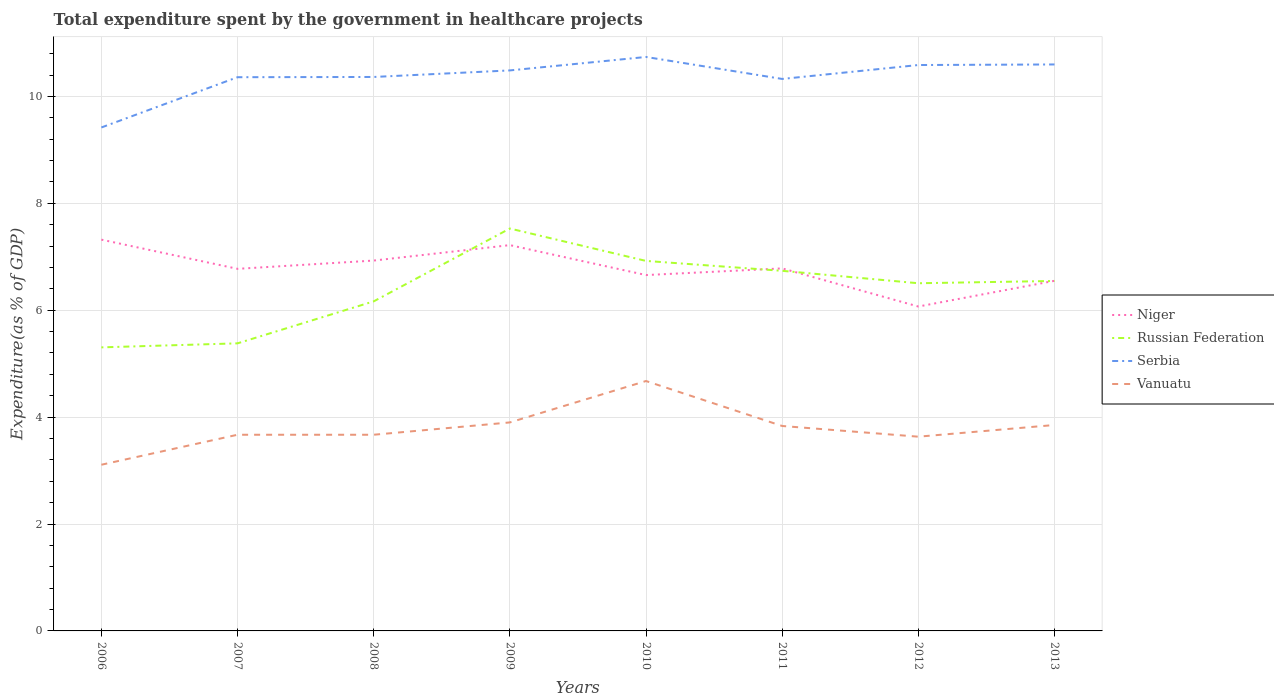How many different coloured lines are there?
Provide a short and direct response. 4. Across all years, what is the maximum total expenditure spent by the government in healthcare projects in Niger?
Provide a succinct answer. 6.07. What is the total total expenditure spent by the government in healthcare projects in Serbia in the graph?
Make the answer very short. 0.14. What is the difference between the highest and the second highest total expenditure spent by the government in healthcare projects in Niger?
Your response must be concise. 1.25. What is the difference between the highest and the lowest total expenditure spent by the government in healthcare projects in Serbia?
Provide a succinct answer. 5. How many lines are there?
Offer a very short reply. 4. How many years are there in the graph?
Make the answer very short. 8. Are the values on the major ticks of Y-axis written in scientific E-notation?
Your answer should be compact. No. Does the graph contain any zero values?
Offer a terse response. No. How are the legend labels stacked?
Make the answer very short. Vertical. What is the title of the graph?
Ensure brevity in your answer.  Total expenditure spent by the government in healthcare projects. Does "Luxembourg" appear as one of the legend labels in the graph?
Keep it short and to the point. No. What is the label or title of the Y-axis?
Offer a terse response. Expenditure(as % of GDP). What is the Expenditure(as % of GDP) of Niger in 2006?
Your response must be concise. 7.32. What is the Expenditure(as % of GDP) in Russian Federation in 2006?
Provide a short and direct response. 5.3. What is the Expenditure(as % of GDP) in Serbia in 2006?
Provide a succinct answer. 9.42. What is the Expenditure(as % of GDP) in Vanuatu in 2006?
Make the answer very short. 3.11. What is the Expenditure(as % of GDP) in Niger in 2007?
Provide a short and direct response. 6.77. What is the Expenditure(as % of GDP) of Russian Federation in 2007?
Ensure brevity in your answer.  5.38. What is the Expenditure(as % of GDP) of Serbia in 2007?
Give a very brief answer. 10.36. What is the Expenditure(as % of GDP) of Vanuatu in 2007?
Your answer should be very brief. 3.67. What is the Expenditure(as % of GDP) in Niger in 2008?
Your answer should be compact. 6.93. What is the Expenditure(as % of GDP) of Russian Federation in 2008?
Ensure brevity in your answer.  6.17. What is the Expenditure(as % of GDP) in Serbia in 2008?
Your answer should be compact. 10.36. What is the Expenditure(as % of GDP) in Vanuatu in 2008?
Offer a very short reply. 3.67. What is the Expenditure(as % of GDP) of Niger in 2009?
Offer a very short reply. 7.22. What is the Expenditure(as % of GDP) in Russian Federation in 2009?
Your answer should be very brief. 7.53. What is the Expenditure(as % of GDP) in Serbia in 2009?
Your response must be concise. 10.49. What is the Expenditure(as % of GDP) in Vanuatu in 2009?
Your answer should be compact. 3.9. What is the Expenditure(as % of GDP) of Niger in 2010?
Your response must be concise. 6.66. What is the Expenditure(as % of GDP) of Russian Federation in 2010?
Provide a succinct answer. 6.92. What is the Expenditure(as % of GDP) in Serbia in 2010?
Ensure brevity in your answer.  10.74. What is the Expenditure(as % of GDP) in Vanuatu in 2010?
Provide a short and direct response. 4.68. What is the Expenditure(as % of GDP) of Niger in 2011?
Your response must be concise. 6.78. What is the Expenditure(as % of GDP) in Russian Federation in 2011?
Give a very brief answer. 6.74. What is the Expenditure(as % of GDP) in Serbia in 2011?
Make the answer very short. 10.33. What is the Expenditure(as % of GDP) in Vanuatu in 2011?
Provide a short and direct response. 3.83. What is the Expenditure(as % of GDP) of Niger in 2012?
Ensure brevity in your answer.  6.07. What is the Expenditure(as % of GDP) in Russian Federation in 2012?
Your response must be concise. 6.5. What is the Expenditure(as % of GDP) in Serbia in 2012?
Your response must be concise. 10.59. What is the Expenditure(as % of GDP) in Vanuatu in 2012?
Keep it short and to the point. 3.63. What is the Expenditure(as % of GDP) of Niger in 2013?
Your answer should be compact. 6.55. What is the Expenditure(as % of GDP) of Russian Federation in 2013?
Offer a terse response. 6.55. What is the Expenditure(as % of GDP) in Serbia in 2013?
Your answer should be compact. 10.6. What is the Expenditure(as % of GDP) of Vanuatu in 2013?
Your answer should be very brief. 3.85. Across all years, what is the maximum Expenditure(as % of GDP) of Niger?
Keep it short and to the point. 7.32. Across all years, what is the maximum Expenditure(as % of GDP) in Russian Federation?
Offer a terse response. 7.53. Across all years, what is the maximum Expenditure(as % of GDP) in Serbia?
Ensure brevity in your answer.  10.74. Across all years, what is the maximum Expenditure(as % of GDP) of Vanuatu?
Ensure brevity in your answer.  4.68. Across all years, what is the minimum Expenditure(as % of GDP) in Niger?
Your answer should be very brief. 6.07. Across all years, what is the minimum Expenditure(as % of GDP) of Russian Federation?
Offer a very short reply. 5.3. Across all years, what is the minimum Expenditure(as % of GDP) of Serbia?
Make the answer very short. 9.42. Across all years, what is the minimum Expenditure(as % of GDP) of Vanuatu?
Provide a short and direct response. 3.11. What is the total Expenditure(as % of GDP) in Niger in the graph?
Your answer should be very brief. 54.3. What is the total Expenditure(as % of GDP) of Russian Federation in the graph?
Provide a succinct answer. 51.09. What is the total Expenditure(as % of GDP) of Serbia in the graph?
Offer a terse response. 82.87. What is the total Expenditure(as % of GDP) of Vanuatu in the graph?
Ensure brevity in your answer.  30.34. What is the difference between the Expenditure(as % of GDP) of Niger in 2006 and that in 2007?
Your response must be concise. 0.55. What is the difference between the Expenditure(as % of GDP) of Russian Federation in 2006 and that in 2007?
Give a very brief answer. -0.08. What is the difference between the Expenditure(as % of GDP) in Serbia in 2006 and that in 2007?
Your answer should be very brief. -0.94. What is the difference between the Expenditure(as % of GDP) in Vanuatu in 2006 and that in 2007?
Your response must be concise. -0.56. What is the difference between the Expenditure(as % of GDP) in Niger in 2006 and that in 2008?
Keep it short and to the point. 0.39. What is the difference between the Expenditure(as % of GDP) of Russian Federation in 2006 and that in 2008?
Offer a terse response. -0.86. What is the difference between the Expenditure(as % of GDP) in Serbia in 2006 and that in 2008?
Provide a short and direct response. -0.94. What is the difference between the Expenditure(as % of GDP) in Vanuatu in 2006 and that in 2008?
Ensure brevity in your answer.  -0.56. What is the difference between the Expenditure(as % of GDP) in Niger in 2006 and that in 2009?
Provide a short and direct response. 0.1. What is the difference between the Expenditure(as % of GDP) in Russian Federation in 2006 and that in 2009?
Your answer should be compact. -2.22. What is the difference between the Expenditure(as % of GDP) of Serbia in 2006 and that in 2009?
Provide a short and direct response. -1.07. What is the difference between the Expenditure(as % of GDP) of Vanuatu in 2006 and that in 2009?
Give a very brief answer. -0.79. What is the difference between the Expenditure(as % of GDP) of Niger in 2006 and that in 2010?
Provide a succinct answer. 0.66. What is the difference between the Expenditure(as % of GDP) in Russian Federation in 2006 and that in 2010?
Give a very brief answer. -1.62. What is the difference between the Expenditure(as % of GDP) in Serbia in 2006 and that in 2010?
Give a very brief answer. -1.32. What is the difference between the Expenditure(as % of GDP) in Vanuatu in 2006 and that in 2010?
Give a very brief answer. -1.57. What is the difference between the Expenditure(as % of GDP) in Niger in 2006 and that in 2011?
Make the answer very short. 0.54. What is the difference between the Expenditure(as % of GDP) in Russian Federation in 2006 and that in 2011?
Your answer should be very brief. -1.43. What is the difference between the Expenditure(as % of GDP) in Serbia in 2006 and that in 2011?
Your response must be concise. -0.91. What is the difference between the Expenditure(as % of GDP) of Vanuatu in 2006 and that in 2011?
Provide a succinct answer. -0.73. What is the difference between the Expenditure(as % of GDP) in Niger in 2006 and that in 2012?
Make the answer very short. 1.25. What is the difference between the Expenditure(as % of GDP) of Russian Federation in 2006 and that in 2012?
Your answer should be very brief. -1.2. What is the difference between the Expenditure(as % of GDP) of Serbia in 2006 and that in 2012?
Your response must be concise. -1.17. What is the difference between the Expenditure(as % of GDP) in Vanuatu in 2006 and that in 2012?
Give a very brief answer. -0.52. What is the difference between the Expenditure(as % of GDP) in Niger in 2006 and that in 2013?
Your answer should be very brief. 0.77. What is the difference between the Expenditure(as % of GDP) in Russian Federation in 2006 and that in 2013?
Provide a succinct answer. -1.24. What is the difference between the Expenditure(as % of GDP) of Serbia in 2006 and that in 2013?
Make the answer very short. -1.18. What is the difference between the Expenditure(as % of GDP) of Vanuatu in 2006 and that in 2013?
Your answer should be compact. -0.74. What is the difference between the Expenditure(as % of GDP) of Niger in 2007 and that in 2008?
Offer a terse response. -0.15. What is the difference between the Expenditure(as % of GDP) of Russian Federation in 2007 and that in 2008?
Offer a terse response. -0.79. What is the difference between the Expenditure(as % of GDP) of Serbia in 2007 and that in 2008?
Provide a short and direct response. -0. What is the difference between the Expenditure(as % of GDP) in Niger in 2007 and that in 2009?
Offer a very short reply. -0.44. What is the difference between the Expenditure(as % of GDP) of Russian Federation in 2007 and that in 2009?
Provide a succinct answer. -2.15. What is the difference between the Expenditure(as % of GDP) of Serbia in 2007 and that in 2009?
Offer a terse response. -0.13. What is the difference between the Expenditure(as % of GDP) of Vanuatu in 2007 and that in 2009?
Offer a very short reply. -0.23. What is the difference between the Expenditure(as % of GDP) of Niger in 2007 and that in 2010?
Keep it short and to the point. 0.12. What is the difference between the Expenditure(as % of GDP) of Russian Federation in 2007 and that in 2010?
Provide a succinct answer. -1.54. What is the difference between the Expenditure(as % of GDP) in Serbia in 2007 and that in 2010?
Your response must be concise. -0.38. What is the difference between the Expenditure(as % of GDP) of Vanuatu in 2007 and that in 2010?
Provide a succinct answer. -1.01. What is the difference between the Expenditure(as % of GDP) in Niger in 2007 and that in 2011?
Ensure brevity in your answer.  -0.01. What is the difference between the Expenditure(as % of GDP) of Russian Federation in 2007 and that in 2011?
Ensure brevity in your answer.  -1.36. What is the difference between the Expenditure(as % of GDP) of Serbia in 2007 and that in 2011?
Provide a succinct answer. 0.03. What is the difference between the Expenditure(as % of GDP) of Vanuatu in 2007 and that in 2011?
Make the answer very short. -0.16. What is the difference between the Expenditure(as % of GDP) of Niger in 2007 and that in 2012?
Offer a terse response. 0.71. What is the difference between the Expenditure(as % of GDP) of Russian Federation in 2007 and that in 2012?
Give a very brief answer. -1.12. What is the difference between the Expenditure(as % of GDP) of Serbia in 2007 and that in 2012?
Provide a succinct answer. -0.23. What is the difference between the Expenditure(as % of GDP) of Vanuatu in 2007 and that in 2012?
Your response must be concise. 0.04. What is the difference between the Expenditure(as % of GDP) in Niger in 2007 and that in 2013?
Ensure brevity in your answer.  0.22. What is the difference between the Expenditure(as % of GDP) of Russian Federation in 2007 and that in 2013?
Give a very brief answer. -1.17. What is the difference between the Expenditure(as % of GDP) of Serbia in 2007 and that in 2013?
Make the answer very short. -0.24. What is the difference between the Expenditure(as % of GDP) in Vanuatu in 2007 and that in 2013?
Give a very brief answer. -0.18. What is the difference between the Expenditure(as % of GDP) of Niger in 2008 and that in 2009?
Provide a short and direct response. -0.29. What is the difference between the Expenditure(as % of GDP) in Russian Federation in 2008 and that in 2009?
Ensure brevity in your answer.  -1.36. What is the difference between the Expenditure(as % of GDP) in Serbia in 2008 and that in 2009?
Give a very brief answer. -0.12. What is the difference between the Expenditure(as % of GDP) of Vanuatu in 2008 and that in 2009?
Give a very brief answer. -0.23. What is the difference between the Expenditure(as % of GDP) of Niger in 2008 and that in 2010?
Provide a succinct answer. 0.27. What is the difference between the Expenditure(as % of GDP) of Russian Federation in 2008 and that in 2010?
Ensure brevity in your answer.  -0.76. What is the difference between the Expenditure(as % of GDP) in Serbia in 2008 and that in 2010?
Offer a very short reply. -0.37. What is the difference between the Expenditure(as % of GDP) in Vanuatu in 2008 and that in 2010?
Ensure brevity in your answer.  -1.01. What is the difference between the Expenditure(as % of GDP) of Niger in 2008 and that in 2011?
Your answer should be very brief. 0.15. What is the difference between the Expenditure(as % of GDP) in Russian Federation in 2008 and that in 2011?
Make the answer very short. -0.57. What is the difference between the Expenditure(as % of GDP) in Serbia in 2008 and that in 2011?
Offer a terse response. 0.04. What is the difference between the Expenditure(as % of GDP) of Vanuatu in 2008 and that in 2011?
Make the answer very short. -0.16. What is the difference between the Expenditure(as % of GDP) in Niger in 2008 and that in 2012?
Ensure brevity in your answer.  0.86. What is the difference between the Expenditure(as % of GDP) of Russian Federation in 2008 and that in 2012?
Ensure brevity in your answer.  -0.34. What is the difference between the Expenditure(as % of GDP) in Serbia in 2008 and that in 2012?
Your answer should be compact. -0.22. What is the difference between the Expenditure(as % of GDP) of Vanuatu in 2008 and that in 2012?
Provide a short and direct response. 0.04. What is the difference between the Expenditure(as % of GDP) in Niger in 2008 and that in 2013?
Your response must be concise. 0.38. What is the difference between the Expenditure(as % of GDP) of Russian Federation in 2008 and that in 2013?
Offer a very short reply. -0.38. What is the difference between the Expenditure(as % of GDP) in Serbia in 2008 and that in 2013?
Your answer should be compact. -0.23. What is the difference between the Expenditure(as % of GDP) in Vanuatu in 2008 and that in 2013?
Keep it short and to the point. -0.18. What is the difference between the Expenditure(as % of GDP) in Niger in 2009 and that in 2010?
Provide a short and direct response. 0.56. What is the difference between the Expenditure(as % of GDP) in Russian Federation in 2009 and that in 2010?
Provide a succinct answer. 0.61. What is the difference between the Expenditure(as % of GDP) in Serbia in 2009 and that in 2010?
Your answer should be compact. -0.25. What is the difference between the Expenditure(as % of GDP) of Vanuatu in 2009 and that in 2010?
Provide a short and direct response. -0.77. What is the difference between the Expenditure(as % of GDP) in Niger in 2009 and that in 2011?
Make the answer very short. 0.44. What is the difference between the Expenditure(as % of GDP) of Russian Federation in 2009 and that in 2011?
Your response must be concise. 0.79. What is the difference between the Expenditure(as % of GDP) in Serbia in 2009 and that in 2011?
Provide a succinct answer. 0.16. What is the difference between the Expenditure(as % of GDP) in Vanuatu in 2009 and that in 2011?
Ensure brevity in your answer.  0.07. What is the difference between the Expenditure(as % of GDP) in Niger in 2009 and that in 2012?
Your response must be concise. 1.15. What is the difference between the Expenditure(as % of GDP) in Russian Federation in 2009 and that in 2012?
Offer a terse response. 1.02. What is the difference between the Expenditure(as % of GDP) in Serbia in 2009 and that in 2012?
Provide a succinct answer. -0.1. What is the difference between the Expenditure(as % of GDP) in Vanuatu in 2009 and that in 2012?
Your answer should be compact. 0.27. What is the difference between the Expenditure(as % of GDP) of Niger in 2009 and that in 2013?
Make the answer very short. 0.67. What is the difference between the Expenditure(as % of GDP) in Russian Federation in 2009 and that in 2013?
Give a very brief answer. 0.98. What is the difference between the Expenditure(as % of GDP) of Serbia in 2009 and that in 2013?
Offer a very short reply. -0.11. What is the difference between the Expenditure(as % of GDP) in Vanuatu in 2009 and that in 2013?
Make the answer very short. 0.05. What is the difference between the Expenditure(as % of GDP) of Niger in 2010 and that in 2011?
Offer a very short reply. -0.12. What is the difference between the Expenditure(as % of GDP) in Russian Federation in 2010 and that in 2011?
Offer a very short reply. 0.19. What is the difference between the Expenditure(as % of GDP) in Serbia in 2010 and that in 2011?
Make the answer very short. 0.41. What is the difference between the Expenditure(as % of GDP) in Vanuatu in 2010 and that in 2011?
Offer a very short reply. 0.84. What is the difference between the Expenditure(as % of GDP) in Niger in 2010 and that in 2012?
Your answer should be compact. 0.59. What is the difference between the Expenditure(as % of GDP) in Russian Federation in 2010 and that in 2012?
Your answer should be compact. 0.42. What is the difference between the Expenditure(as % of GDP) in Serbia in 2010 and that in 2012?
Give a very brief answer. 0.15. What is the difference between the Expenditure(as % of GDP) in Vanuatu in 2010 and that in 2012?
Offer a very short reply. 1.04. What is the difference between the Expenditure(as % of GDP) in Niger in 2010 and that in 2013?
Provide a short and direct response. 0.11. What is the difference between the Expenditure(as % of GDP) in Russian Federation in 2010 and that in 2013?
Your answer should be very brief. 0.37. What is the difference between the Expenditure(as % of GDP) in Serbia in 2010 and that in 2013?
Provide a succinct answer. 0.14. What is the difference between the Expenditure(as % of GDP) of Vanuatu in 2010 and that in 2013?
Your response must be concise. 0.82. What is the difference between the Expenditure(as % of GDP) of Niger in 2011 and that in 2012?
Provide a succinct answer. 0.71. What is the difference between the Expenditure(as % of GDP) of Russian Federation in 2011 and that in 2012?
Your answer should be compact. 0.23. What is the difference between the Expenditure(as % of GDP) in Serbia in 2011 and that in 2012?
Your response must be concise. -0.26. What is the difference between the Expenditure(as % of GDP) of Vanuatu in 2011 and that in 2012?
Your answer should be very brief. 0.2. What is the difference between the Expenditure(as % of GDP) of Niger in 2011 and that in 2013?
Keep it short and to the point. 0.23. What is the difference between the Expenditure(as % of GDP) in Russian Federation in 2011 and that in 2013?
Provide a succinct answer. 0.19. What is the difference between the Expenditure(as % of GDP) of Serbia in 2011 and that in 2013?
Provide a short and direct response. -0.27. What is the difference between the Expenditure(as % of GDP) in Vanuatu in 2011 and that in 2013?
Give a very brief answer. -0.02. What is the difference between the Expenditure(as % of GDP) of Niger in 2012 and that in 2013?
Your answer should be very brief. -0.48. What is the difference between the Expenditure(as % of GDP) of Russian Federation in 2012 and that in 2013?
Offer a terse response. -0.04. What is the difference between the Expenditure(as % of GDP) in Serbia in 2012 and that in 2013?
Give a very brief answer. -0.01. What is the difference between the Expenditure(as % of GDP) of Vanuatu in 2012 and that in 2013?
Provide a succinct answer. -0.22. What is the difference between the Expenditure(as % of GDP) in Niger in 2006 and the Expenditure(as % of GDP) in Russian Federation in 2007?
Your answer should be compact. 1.94. What is the difference between the Expenditure(as % of GDP) in Niger in 2006 and the Expenditure(as % of GDP) in Serbia in 2007?
Make the answer very short. -3.04. What is the difference between the Expenditure(as % of GDP) in Niger in 2006 and the Expenditure(as % of GDP) in Vanuatu in 2007?
Your answer should be very brief. 3.65. What is the difference between the Expenditure(as % of GDP) in Russian Federation in 2006 and the Expenditure(as % of GDP) in Serbia in 2007?
Your answer should be very brief. -5.05. What is the difference between the Expenditure(as % of GDP) of Russian Federation in 2006 and the Expenditure(as % of GDP) of Vanuatu in 2007?
Offer a terse response. 1.63. What is the difference between the Expenditure(as % of GDP) of Serbia in 2006 and the Expenditure(as % of GDP) of Vanuatu in 2007?
Your answer should be compact. 5.75. What is the difference between the Expenditure(as % of GDP) of Niger in 2006 and the Expenditure(as % of GDP) of Russian Federation in 2008?
Your answer should be very brief. 1.15. What is the difference between the Expenditure(as % of GDP) of Niger in 2006 and the Expenditure(as % of GDP) of Serbia in 2008?
Your answer should be compact. -3.04. What is the difference between the Expenditure(as % of GDP) of Niger in 2006 and the Expenditure(as % of GDP) of Vanuatu in 2008?
Keep it short and to the point. 3.65. What is the difference between the Expenditure(as % of GDP) in Russian Federation in 2006 and the Expenditure(as % of GDP) in Serbia in 2008?
Offer a very short reply. -5.06. What is the difference between the Expenditure(as % of GDP) of Russian Federation in 2006 and the Expenditure(as % of GDP) of Vanuatu in 2008?
Offer a very short reply. 1.63. What is the difference between the Expenditure(as % of GDP) in Serbia in 2006 and the Expenditure(as % of GDP) in Vanuatu in 2008?
Your response must be concise. 5.75. What is the difference between the Expenditure(as % of GDP) in Niger in 2006 and the Expenditure(as % of GDP) in Russian Federation in 2009?
Give a very brief answer. -0.21. What is the difference between the Expenditure(as % of GDP) in Niger in 2006 and the Expenditure(as % of GDP) in Serbia in 2009?
Make the answer very short. -3.17. What is the difference between the Expenditure(as % of GDP) of Niger in 2006 and the Expenditure(as % of GDP) of Vanuatu in 2009?
Keep it short and to the point. 3.42. What is the difference between the Expenditure(as % of GDP) in Russian Federation in 2006 and the Expenditure(as % of GDP) in Serbia in 2009?
Your answer should be compact. -5.18. What is the difference between the Expenditure(as % of GDP) in Russian Federation in 2006 and the Expenditure(as % of GDP) in Vanuatu in 2009?
Your answer should be very brief. 1.4. What is the difference between the Expenditure(as % of GDP) in Serbia in 2006 and the Expenditure(as % of GDP) in Vanuatu in 2009?
Offer a very short reply. 5.52. What is the difference between the Expenditure(as % of GDP) in Niger in 2006 and the Expenditure(as % of GDP) in Russian Federation in 2010?
Your answer should be compact. 0.4. What is the difference between the Expenditure(as % of GDP) of Niger in 2006 and the Expenditure(as % of GDP) of Serbia in 2010?
Offer a terse response. -3.42. What is the difference between the Expenditure(as % of GDP) of Niger in 2006 and the Expenditure(as % of GDP) of Vanuatu in 2010?
Your response must be concise. 2.64. What is the difference between the Expenditure(as % of GDP) of Russian Federation in 2006 and the Expenditure(as % of GDP) of Serbia in 2010?
Your answer should be very brief. -5.43. What is the difference between the Expenditure(as % of GDP) in Russian Federation in 2006 and the Expenditure(as % of GDP) in Vanuatu in 2010?
Your answer should be compact. 0.63. What is the difference between the Expenditure(as % of GDP) in Serbia in 2006 and the Expenditure(as % of GDP) in Vanuatu in 2010?
Offer a terse response. 4.74. What is the difference between the Expenditure(as % of GDP) of Niger in 2006 and the Expenditure(as % of GDP) of Russian Federation in 2011?
Give a very brief answer. 0.58. What is the difference between the Expenditure(as % of GDP) in Niger in 2006 and the Expenditure(as % of GDP) in Serbia in 2011?
Offer a terse response. -3.01. What is the difference between the Expenditure(as % of GDP) of Niger in 2006 and the Expenditure(as % of GDP) of Vanuatu in 2011?
Provide a succinct answer. 3.49. What is the difference between the Expenditure(as % of GDP) in Russian Federation in 2006 and the Expenditure(as % of GDP) in Serbia in 2011?
Provide a short and direct response. -5.02. What is the difference between the Expenditure(as % of GDP) in Russian Federation in 2006 and the Expenditure(as % of GDP) in Vanuatu in 2011?
Ensure brevity in your answer.  1.47. What is the difference between the Expenditure(as % of GDP) in Serbia in 2006 and the Expenditure(as % of GDP) in Vanuatu in 2011?
Your answer should be very brief. 5.58. What is the difference between the Expenditure(as % of GDP) of Niger in 2006 and the Expenditure(as % of GDP) of Russian Federation in 2012?
Give a very brief answer. 0.82. What is the difference between the Expenditure(as % of GDP) of Niger in 2006 and the Expenditure(as % of GDP) of Serbia in 2012?
Your answer should be very brief. -3.27. What is the difference between the Expenditure(as % of GDP) in Niger in 2006 and the Expenditure(as % of GDP) in Vanuatu in 2012?
Keep it short and to the point. 3.69. What is the difference between the Expenditure(as % of GDP) of Russian Federation in 2006 and the Expenditure(as % of GDP) of Serbia in 2012?
Provide a succinct answer. -5.28. What is the difference between the Expenditure(as % of GDP) of Russian Federation in 2006 and the Expenditure(as % of GDP) of Vanuatu in 2012?
Provide a short and direct response. 1.67. What is the difference between the Expenditure(as % of GDP) of Serbia in 2006 and the Expenditure(as % of GDP) of Vanuatu in 2012?
Your answer should be very brief. 5.78. What is the difference between the Expenditure(as % of GDP) of Niger in 2006 and the Expenditure(as % of GDP) of Russian Federation in 2013?
Your answer should be compact. 0.77. What is the difference between the Expenditure(as % of GDP) of Niger in 2006 and the Expenditure(as % of GDP) of Serbia in 2013?
Your answer should be compact. -3.28. What is the difference between the Expenditure(as % of GDP) in Niger in 2006 and the Expenditure(as % of GDP) in Vanuatu in 2013?
Offer a very short reply. 3.47. What is the difference between the Expenditure(as % of GDP) in Russian Federation in 2006 and the Expenditure(as % of GDP) in Serbia in 2013?
Give a very brief answer. -5.29. What is the difference between the Expenditure(as % of GDP) of Russian Federation in 2006 and the Expenditure(as % of GDP) of Vanuatu in 2013?
Give a very brief answer. 1.45. What is the difference between the Expenditure(as % of GDP) of Serbia in 2006 and the Expenditure(as % of GDP) of Vanuatu in 2013?
Your response must be concise. 5.57. What is the difference between the Expenditure(as % of GDP) in Niger in 2007 and the Expenditure(as % of GDP) in Russian Federation in 2008?
Keep it short and to the point. 0.61. What is the difference between the Expenditure(as % of GDP) in Niger in 2007 and the Expenditure(as % of GDP) in Serbia in 2008?
Keep it short and to the point. -3.59. What is the difference between the Expenditure(as % of GDP) of Niger in 2007 and the Expenditure(as % of GDP) of Vanuatu in 2008?
Your answer should be very brief. 3.1. What is the difference between the Expenditure(as % of GDP) of Russian Federation in 2007 and the Expenditure(as % of GDP) of Serbia in 2008?
Your answer should be compact. -4.98. What is the difference between the Expenditure(as % of GDP) of Russian Federation in 2007 and the Expenditure(as % of GDP) of Vanuatu in 2008?
Keep it short and to the point. 1.71. What is the difference between the Expenditure(as % of GDP) in Serbia in 2007 and the Expenditure(as % of GDP) in Vanuatu in 2008?
Your response must be concise. 6.69. What is the difference between the Expenditure(as % of GDP) in Niger in 2007 and the Expenditure(as % of GDP) in Russian Federation in 2009?
Offer a terse response. -0.75. What is the difference between the Expenditure(as % of GDP) in Niger in 2007 and the Expenditure(as % of GDP) in Serbia in 2009?
Ensure brevity in your answer.  -3.71. What is the difference between the Expenditure(as % of GDP) in Niger in 2007 and the Expenditure(as % of GDP) in Vanuatu in 2009?
Ensure brevity in your answer.  2.87. What is the difference between the Expenditure(as % of GDP) of Russian Federation in 2007 and the Expenditure(as % of GDP) of Serbia in 2009?
Ensure brevity in your answer.  -5.11. What is the difference between the Expenditure(as % of GDP) of Russian Federation in 2007 and the Expenditure(as % of GDP) of Vanuatu in 2009?
Ensure brevity in your answer.  1.48. What is the difference between the Expenditure(as % of GDP) in Serbia in 2007 and the Expenditure(as % of GDP) in Vanuatu in 2009?
Make the answer very short. 6.46. What is the difference between the Expenditure(as % of GDP) in Niger in 2007 and the Expenditure(as % of GDP) in Russian Federation in 2010?
Offer a very short reply. -0.15. What is the difference between the Expenditure(as % of GDP) of Niger in 2007 and the Expenditure(as % of GDP) of Serbia in 2010?
Make the answer very short. -3.96. What is the difference between the Expenditure(as % of GDP) in Niger in 2007 and the Expenditure(as % of GDP) in Vanuatu in 2010?
Your answer should be compact. 2.1. What is the difference between the Expenditure(as % of GDP) of Russian Federation in 2007 and the Expenditure(as % of GDP) of Serbia in 2010?
Provide a short and direct response. -5.36. What is the difference between the Expenditure(as % of GDP) of Russian Federation in 2007 and the Expenditure(as % of GDP) of Vanuatu in 2010?
Provide a short and direct response. 0.7. What is the difference between the Expenditure(as % of GDP) of Serbia in 2007 and the Expenditure(as % of GDP) of Vanuatu in 2010?
Provide a succinct answer. 5.68. What is the difference between the Expenditure(as % of GDP) in Niger in 2007 and the Expenditure(as % of GDP) in Russian Federation in 2011?
Provide a short and direct response. 0.04. What is the difference between the Expenditure(as % of GDP) in Niger in 2007 and the Expenditure(as % of GDP) in Serbia in 2011?
Your answer should be very brief. -3.55. What is the difference between the Expenditure(as % of GDP) in Niger in 2007 and the Expenditure(as % of GDP) in Vanuatu in 2011?
Ensure brevity in your answer.  2.94. What is the difference between the Expenditure(as % of GDP) of Russian Federation in 2007 and the Expenditure(as % of GDP) of Serbia in 2011?
Give a very brief answer. -4.95. What is the difference between the Expenditure(as % of GDP) of Russian Federation in 2007 and the Expenditure(as % of GDP) of Vanuatu in 2011?
Make the answer very short. 1.55. What is the difference between the Expenditure(as % of GDP) of Serbia in 2007 and the Expenditure(as % of GDP) of Vanuatu in 2011?
Make the answer very short. 6.52. What is the difference between the Expenditure(as % of GDP) of Niger in 2007 and the Expenditure(as % of GDP) of Russian Federation in 2012?
Your answer should be very brief. 0.27. What is the difference between the Expenditure(as % of GDP) of Niger in 2007 and the Expenditure(as % of GDP) of Serbia in 2012?
Keep it short and to the point. -3.81. What is the difference between the Expenditure(as % of GDP) of Niger in 2007 and the Expenditure(as % of GDP) of Vanuatu in 2012?
Offer a terse response. 3.14. What is the difference between the Expenditure(as % of GDP) of Russian Federation in 2007 and the Expenditure(as % of GDP) of Serbia in 2012?
Offer a terse response. -5.21. What is the difference between the Expenditure(as % of GDP) in Russian Federation in 2007 and the Expenditure(as % of GDP) in Vanuatu in 2012?
Your answer should be compact. 1.75. What is the difference between the Expenditure(as % of GDP) in Serbia in 2007 and the Expenditure(as % of GDP) in Vanuatu in 2012?
Provide a succinct answer. 6.73. What is the difference between the Expenditure(as % of GDP) in Niger in 2007 and the Expenditure(as % of GDP) in Russian Federation in 2013?
Your response must be concise. 0.23. What is the difference between the Expenditure(as % of GDP) of Niger in 2007 and the Expenditure(as % of GDP) of Serbia in 2013?
Give a very brief answer. -3.82. What is the difference between the Expenditure(as % of GDP) in Niger in 2007 and the Expenditure(as % of GDP) in Vanuatu in 2013?
Your answer should be very brief. 2.92. What is the difference between the Expenditure(as % of GDP) of Russian Federation in 2007 and the Expenditure(as % of GDP) of Serbia in 2013?
Your answer should be compact. -5.22. What is the difference between the Expenditure(as % of GDP) in Russian Federation in 2007 and the Expenditure(as % of GDP) in Vanuatu in 2013?
Make the answer very short. 1.53. What is the difference between the Expenditure(as % of GDP) in Serbia in 2007 and the Expenditure(as % of GDP) in Vanuatu in 2013?
Your response must be concise. 6.51. What is the difference between the Expenditure(as % of GDP) in Niger in 2008 and the Expenditure(as % of GDP) in Russian Federation in 2009?
Your answer should be compact. -0.6. What is the difference between the Expenditure(as % of GDP) of Niger in 2008 and the Expenditure(as % of GDP) of Serbia in 2009?
Ensure brevity in your answer.  -3.56. What is the difference between the Expenditure(as % of GDP) of Niger in 2008 and the Expenditure(as % of GDP) of Vanuatu in 2009?
Your response must be concise. 3.03. What is the difference between the Expenditure(as % of GDP) of Russian Federation in 2008 and the Expenditure(as % of GDP) of Serbia in 2009?
Provide a short and direct response. -4.32. What is the difference between the Expenditure(as % of GDP) of Russian Federation in 2008 and the Expenditure(as % of GDP) of Vanuatu in 2009?
Make the answer very short. 2.26. What is the difference between the Expenditure(as % of GDP) of Serbia in 2008 and the Expenditure(as % of GDP) of Vanuatu in 2009?
Give a very brief answer. 6.46. What is the difference between the Expenditure(as % of GDP) in Niger in 2008 and the Expenditure(as % of GDP) in Russian Federation in 2010?
Make the answer very short. 0.01. What is the difference between the Expenditure(as % of GDP) in Niger in 2008 and the Expenditure(as % of GDP) in Serbia in 2010?
Give a very brief answer. -3.81. What is the difference between the Expenditure(as % of GDP) in Niger in 2008 and the Expenditure(as % of GDP) in Vanuatu in 2010?
Offer a very short reply. 2.25. What is the difference between the Expenditure(as % of GDP) of Russian Federation in 2008 and the Expenditure(as % of GDP) of Serbia in 2010?
Your answer should be very brief. -4.57. What is the difference between the Expenditure(as % of GDP) in Russian Federation in 2008 and the Expenditure(as % of GDP) in Vanuatu in 2010?
Give a very brief answer. 1.49. What is the difference between the Expenditure(as % of GDP) of Serbia in 2008 and the Expenditure(as % of GDP) of Vanuatu in 2010?
Provide a short and direct response. 5.69. What is the difference between the Expenditure(as % of GDP) in Niger in 2008 and the Expenditure(as % of GDP) in Russian Federation in 2011?
Your answer should be very brief. 0.19. What is the difference between the Expenditure(as % of GDP) in Niger in 2008 and the Expenditure(as % of GDP) in Serbia in 2011?
Make the answer very short. -3.4. What is the difference between the Expenditure(as % of GDP) in Niger in 2008 and the Expenditure(as % of GDP) in Vanuatu in 2011?
Keep it short and to the point. 3.09. What is the difference between the Expenditure(as % of GDP) of Russian Federation in 2008 and the Expenditure(as % of GDP) of Serbia in 2011?
Your response must be concise. -4.16. What is the difference between the Expenditure(as % of GDP) in Russian Federation in 2008 and the Expenditure(as % of GDP) in Vanuatu in 2011?
Make the answer very short. 2.33. What is the difference between the Expenditure(as % of GDP) in Serbia in 2008 and the Expenditure(as % of GDP) in Vanuatu in 2011?
Give a very brief answer. 6.53. What is the difference between the Expenditure(as % of GDP) of Niger in 2008 and the Expenditure(as % of GDP) of Russian Federation in 2012?
Provide a succinct answer. 0.42. What is the difference between the Expenditure(as % of GDP) of Niger in 2008 and the Expenditure(as % of GDP) of Serbia in 2012?
Keep it short and to the point. -3.66. What is the difference between the Expenditure(as % of GDP) of Niger in 2008 and the Expenditure(as % of GDP) of Vanuatu in 2012?
Make the answer very short. 3.29. What is the difference between the Expenditure(as % of GDP) in Russian Federation in 2008 and the Expenditure(as % of GDP) in Serbia in 2012?
Provide a short and direct response. -4.42. What is the difference between the Expenditure(as % of GDP) of Russian Federation in 2008 and the Expenditure(as % of GDP) of Vanuatu in 2012?
Keep it short and to the point. 2.53. What is the difference between the Expenditure(as % of GDP) of Serbia in 2008 and the Expenditure(as % of GDP) of Vanuatu in 2012?
Offer a very short reply. 6.73. What is the difference between the Expenditure(as % of GDP) of Niger in 2008 and the Expenditure(as % of GDP) of Russian Federation in 2013?
Offer a very short reply. 0.38. What is the difference between the Expenditure(as % of GDP) in Niger in 2008 and the Expenditure(as % of GDP) in Serbia in 2013?
Give a very brief answer. -3.67. What is the difference between the Expenditure(as % of GDP) of Niger in 2008 and the Expenditure(as % of GDP) of Vanuatu in 2013?
Offer a terse response. 3.08. What is the difference between the Expenditure(as % of GDP) in Russian Federation in 2008 and the Expenditure(as % of GDP) in Serbia in 2013?
Offer a very short reply. -4.43. What is the difference between the Expenditure(as % of GDP) in Russian Federation in 2008 and the Expenditure(as % of GDP) in Vanuatu in 2013?
Your response must be concise. 2.31. What is the difference between the Expenditure(as % of GDP) of Serbia in 2008 and the Expenditure(as % of GDP) of Vanuatu in 2013?
Provide a short and direct response. 6.51. What is the difference between the Expenditure(as % of GDP) in Niger in 2009 and the Expenditure(as % of GDP) in Russian Federation in 2010?
Make the answer very short. 0.3. What is the difference between the Expenditure(as % of GDP) of Niger in 2009 and the Expenditure(as % of GDP) of Serbia in 2010?
Give a very brief answer. -3.52. What is the difference between the Expenditure(as % of GDP) in Niger in 2009 and the Expenditure(as % of GDP) in Vanuatu in 2010?
Provide a short and direct response. 2.54. What is the difference between the Expenditure(as % of GDP) in Russian Federation in 2009 and the Expenditure(as % of GDP) in Serbia in 2010?
Provide a succinct answer. -3.21. What is the difference between the Expenditure(as % of GDP) of Russian Federation in 2009 and the Expenditure(as % of GDP) of Vanuatu in 2010?
Keep it short and to the point. 2.85. What is the difference between the Expenditure(as % of GDP) in Serbia in 2009 and the Expenditure(as % of GDP) in Vanuatu in 2010?
Your answer should be compact. 5.81. What is the difference between the Expenditure(as % of GDP) in Niger in 2009 and the Expenditure(as % of GDP) in Russian Federation in 2011?
Provide a short and direct response. 0.48. What is the difference between the Expenditure(as % of GDP) of Niger in 2009 and the Expenditure(as % of GDP) of Serbia in 2011?
Offer a very short reply. -3.11. What is the difference between the Expenditure(as % of GDP) in Niger in 2009 and the Expenditure(as % of GDP) in Vanuatu in 2011?
Provide a succinct answer. 3.38. What is the difference between the Expenditure(as % of GDP) in Russian Federation in 2009 and the Expenditure(as % of GDP) in Serbia in 2011?
Your answer should be very brief. -2.8. What is the difference between the Expenditure(as % of GDP) of Russian Federation in 2009 and the Expenditure(as % of GDP) of Vanuatu in 2011?
Provide a succinct answer. 3.69. What is the difference between the Expenditure(as % of GDP) in Serbia in 2009 and the Expenditure(as % of GDP) in Vanuatu in 2011?
Give a very brief answer. 6.65. What is the difference between the Expenditure(as % of GDP) of Niger in 2009 and the Expenditure(as % of GDP) of Russian Federation in 2012?
Your answer should be compact. 0.71. What is the difference between the Expenditure(as % of GDP) in Niger in 2009 and the Expenditure(as % of GDP) in Serbia in 2012?
Your answer should be very brief. -3.37. What is the difference between the Expenditure(as % of GDP) of Niger in 2009 and the Expenditure(as % of GDP) of Vanuatu in 2012?
Your answer should be very brief. 3.58. What is the difference between the Expenditure(as % of GDP) of Russian Federation in 2009 and the Expenditure(as % of GDP) of Serbia in 2012?
Ensure brevity in your answer.  -3.06. What is the difference between the Expenditure(as % of GDP) in Russian Federation in 2009 and the Expenditure(as % of GDP) in Vanuatu in 2012?
Ensure brevity in your answer.  3.89. What is the difference between the Expenditure(as % of GDP) of Serbia in 2009 and the Expenditure(as % of GDP) of Vanuatu in 2012?
Give a very brief answer. 6.85. What is the difference between the Expenditure(as % of GDP) of Niger in 2009 and the Expenditure(as % of GDP) of Russian Federation in 2013?
Provide a short and direct response. 0.67. What is the difference between the Expenditure(as % of GDP) of Niger in 2009 and the Expenditure(as % of GDP) of Serbia in 2013?
Make the answer very short. -3.38. What is the difference between the Expenditure(as % of GDP) in Niger in 2009 and the Expenditure(as % of GDP) in Vanuatu in 2013?
Offer a terse response. 3.37. What is the difference between the Expenditure(as % of GDP) in Russian Federation in 2009 and the Expenditure(as % of GDP) in Serbia in 2013?
Keep it short and to the point. -3.07. What is the difference between the Expenditure(as % of GDP) of Russian Federation in 2009 and the Expenditure(as % of GDP) of Vanuatu in 2013?
Offer a terse response. 3.68. What is the difference between the Expenditure(as % of GDP) of Serbia in 2009 and the Expenditure(as % of GDP) of Vanuatu in 2013?
Keep it short and to the point. 6.63. What is the difference between the Expenditure(as % of GDP) of Niger in 2010 and the Expenditure(as % of GDP) of Russian Federation in 2011?
Provide a short and direct response. -0.08. What is the difference between the Expenditure(as % of GDP) in Niger in 2010 and the Expenditure(as % of GDP) in Serbia in 2011?
Keep it short and to the point. -3.67. What is the difference between the Expenditure(as % of GDP) in Niger in 2010 and the Expenditure(as % of GDP) in Vanuatu in 2011?
Give a very brief answer. 2.82. What is the difference between the Expenditure(as % of GDP) of Russian Federation in 2010 and the Expenditure(as % of GDP) of Serbia in 2011?
Offer a very short reply. -3.4. What is the difference between the Expenditure(as % of GDP) of Russian Federation in 2010 and the Expenditure(as % of GDP) of Vanuatu in 2011?
Provide a succinct answer. 3.09. What is the difference between the Expenditure(as % of GDP) in Serbia in 2010 and the Expenditure(as % of GDP) in Vanuatu in 2011?
Offer a terse response. 6.9. What is the difference between the Expenditure(as % of GDP) in Niger in 2010 and the Expenditure(as % of GDP) in Russian Federation in 2012?
Ensure brevity in your answer.  0.15. What is the difference between the Expenditure(as % of GDP) of Niger in 2010 and the Expenditure(as % of GDP) of Serbia in 2012?
Your response must be concise. -3.93. What is the difference between the Expenditure(as % of GDP) in Niger in 2010 and the Expenditure(as % of GDP) in Vanuatu in 2012?
Keep it short and to the point. 3.02. What is the difference between the Expenditure(as % of GDP) of Russian Federation in 2010 and the Expenditure(as % of GDP) of Serbia in 2012?
Offer a terse response. -3.66. What is the difference between the Expenditure(as % of GDP) of Russian Federation in 2010 and the Expenditure(as % of GDP) of Vanuatu in 2012?
Ensure brevity in your answer.  3.29. What is the difference between the Expenditure(as % of GDP) of Serbia in 2010 and the Expenditure(as % of GDP) of Vanuatu in 2012?
Your response must be concise. 7.1. What is the difference between the Expenditure(as % of GDP) of Niger in 2010 and the Expenditure(as % of GDP) of Russian Federation in 2013?
Give a very brief answer. 0.11. What is the difference between the Expenditure(as % of GDP) in Niger in 2010 and the Expenditure(as % of GDP) in Serbia in 2013?
Provide a short and direct response. -3.94. What is the difference between the Expenditure(as % of GDP) in Niger in 2010 and the Expenditure(as % of GDP) in Vanuatu in 2013?
Keep it short and to the point. 2.8. What is the difference between the Expenditure(as % of GDP) in Russian Federation in 2010 and the Expenditure(as % of GDP) in Serbia in 2013?
Offer a terse response. -3.68. What is the difference between the Expenditure(as % of GDP) of Russian Federation in 2010 and the Expenditure(as % of GDP) of Vanuatu in 2013?
Offer a very short reply. 3.07. What is the difference between the Expenditure(as % of GDP) in Serbia in 2010 and the Expenditure(as % of GDP) in Vanuatu in 2013?
Provide a short and direct response. 6.89. What is the difference between the Expenditure(as % of GDP) in Niger in 2011 and the Expenditure(as % of GDP) in Russian Federation in 2012?
Make the answer very short. 0.28. What is the difference between the Expenditure(as % of GDP) of Niger in 2011 and the Expenditure(as % of GDP) of Serbia in 2012?
Your answer should be compact. -3.8. What is the difference between the Expenditure(as % of GDP) of Niger in 2011 and the Expenditure(as % of GDP) of Vanuatu in 2012?
Keep it short and to the point. 3.15. What is the difference between the Expenditure(as % of GDP) of Russian Federation in 2011 and the Expenditure(as % of GDP) of Serbia in 2012?
Provide a succinct answer. -3.85. What is the difference between the Expenditure(as % of GDP) in Russian Federation in 2011 and the Expenditure(as % of GDP) in Vanuatu in 2012?
Ensure brevity in your answer.  3.1. What is the difference between the Expenditure(as % of GDP) in Serbia in 2011 and the Expenditure(as % of GDP) in Vanuatu in 2012?
Your answer should be very brief. 6.69. What is the difference between the Expenditure(as % of GDP) of Niger in 2011 and the Expenditure(as % of GDP) of Russian Federation in 2013?
Your answer should be compact. 0.23. What is the difference between the Expenditure(as % of GDP) in Niger in 2011 and the Expenditure(as % of GDP) in Serbia in 2013?
Your answer should be compact. -3.82. What is the difference between the Expenditure(as % of GDP) of Niger in 2011 and the Expenditure(as % of GDP) of Vanuatu in 2013?
Make the answer very short. 2.93. What is the difference between the Expenditure(as % of GDP) in Russian Federation in 2011 and the Expenditure(as % of GDP) in Serbia in 2013?
Make the answer very short. -3.86. What is the difference between the Expenditure(as % of GDP) of Russian Federation in 2011 and the Expenditure(as % of GDP) of Vanuatu in 2013?
Offer a terse response. 2.88. What is the difference between the Expenditure(as % of GDP) in Serbia in 2011 and the Expenditure(as % of GDP) in Vanuatu in 2013?
Make the answer very short. 6.47. What is the difference between the Expenditure(as % of GDP) in Niger in 2012 and the Expenditure(as % of GDP) in Russian Federation in 2013?
Provide a succinct answer. -0.48. What is the difference between the Expenditure(as % of GDP) of Niger in 2012 and the Expenditure(as % of GDP) of Serbia in 2013?
Offer a terse response. -4.53. What is the difference between the Expenditure(as % of GDP) in Niger in 2012 and the Expenditure(as % of GDP) in Vanuatu in 2013?
Give a very brief answer. 2.22. What is the difference between the Expenditure(as % of GDP) of Russian Federation in 2012 and the Expenditure(as % of GDP) of Serbia in 2013?
Offer a very short reply. -4.09. What is the difference between the Expenditure(as % of GDP) of Russian Federation in 2012 and the Expenditure(as % of GDP) of Vanuatu in 2013?
Keep it short and to the point. 2.65. What is the difference between the Expenditure(as % of GDP) in Serbia in 2012 and the Expenditure(as % of GDP) in Vanuatu in 2013?
Offer a terse response. 6.73. What is the average Expenditure(as % of GDP) in Niger per year?
Offer a terse response. 6.79. What is the average Expenditure(as % of GDP) of Russian Federation per year?
Offer a very short reply. 6.39. What is the average Expenditure(as % of GDP) of Serbia per year?
Keep it short and to the point. 10.36. What is the average Expenditure(as % of GDP) in Vanuatu per year?
Give a very brief answer. 3.79. In the year 2006, what is the difference between the Expenditure(as % of GDP) of Niger and Expenditure(as % of GDP) of Russian Federation?
Give a very brief answer. 2.02. In the year 2006, what is the difference between the Expenditure(as % of GDP) of Niger and Expenditure(as % of GDP) of Serbia?
Make the answer very short. -2.1. In the year 2006, what is the difference between the Expenditure(as % of GDP) in Niger and Expenditure(as % of GDP) in Vanuatu?
Give a very brief answer. 4.21. In the year 2006, what is the difference between the Expenditure(as % of GDP) in Russian Federation and Expenditure(as % of GDP) in Serbia?
Your answer should be very brief. -4.11. In the year 2006, what is the difference between the Expenditure(as % of GDP) of Russian Federation and Expenditure(as % of GDP) of Vanuatu?
Your answer should be very brief. 2.2. In the year 2006, what is the difference between the Expenditure(as % of GDP) in Serbia and Expenditure(as % of GDP) in Vanuatu?
Offer a very short reply. 6.31. In the year 2007, what is the difference between the Expenditure(as % of GDP) of Niger and Expenditure(as % of GDP) of Russian Federation?
Give a very brief answer. 1.39. In the year 2007, what is the difference between the Expenditure(as % of GDP) of Niger and Expenditure(as % of GDP) of Serbia?
Provide a short and direct response. -3.58. In the year 2007, what is the difference between the Expenditure(as % of GDP) in Niger and Expenditure(as % of GDP) in Vanuatu?
Your response must be concise. 3.1. In the year 2007, what is the difference between the Expenditure(as % of GDP) of Russian Federation and Expenditure(as % of GDP) of Serbia?
Your answer should be compact. -4.98. In the year 2007, what is the difference between the Expenditure(as % of GDP) in Russian Federation and Expenditure(as % of GDP) in Vanuatu?
Your answer should be very brief. 1.71. In the year 2007, what is the difference between the Expenditure(as % of GDP) of Serbia and Expenditure(as % of GDP) of Vanuatu?
Your response must be concise. 6.69. In the year 2008, what is the difference between the Expenditure(as % of GDP) of Niger and Expenditure(as % of GDP) of Russian Federation?
Keep it short and to the point. 0.76. In the year 2008, what is the difference between the Expenditure(as % of GDP) of Niger and Expenditure(as % of GDP) of Serbia?
Provide a succinct answer. -3.43. In the year 2008, what is the difference between the Expenditure(as % of GDP) in Niger and Expenditure(as % of GDP) in Vanuatu?
Give a very brief answer. 3.26. In the year 2008, what is the difference between the Expenditure(as % of GDP) in Russian Federation and Expenditure(as % of GDP) in Serbia?
Make the answer very short. -4.2. In the year 2008, what is the difference between the Expenditure(as % of GDP) of Russian Federation and Expenditure(as % of GDP) of Vanuatu?
Your response must be concise. 2.5. In the year 2008, what is the difference between the Expenditure(as % of GDP) of Serbia and Expenditure(as % of GDP) of Vanuatu?
Your answer should be compact. 6.69. In the year 2009, what is the difference between the Expenditure(as % of GDP) of Niger and Expenditure(as % of GDP) of Russian Federation?
Offer a very short reply. -0.31. In the year 2009, what is the difference between the Expenditure(as % of GDP) of Niger and Expenditure(as % of GDP) of Serbia?
Provide a short and direct response. -3.27. In the year 2009, what is the difference between the Expenditure(as % of GDP) in Niger and Expenditure(as % of GDP) in Vanuatu?
Provide a short and direct response. 3.32. In the year 2009, what is the difference between the Expenditure(as % of GDP) in Russian Federation and Expenditure(as % of GDP) in Serbia?
Provide a short and direct response. -2.96. In the year 2009, what is the difference between the Expenditure(as % of GDP) in Russian Federation and Expenditure(as % of GDP) in Vanuatu?
Your answer should be very brief. 3.63. In the year 2009, what is the difference between the Expenditure(as % of GDP) in Serbia and Expenditure(as % of GDP) in Vanuatu?
Keep it short and to the point. 6.59. In the year 2010, what is the difference between the Expenditure(as % of GDP) of Niger and Expenditure(as % of GDP) of Russian Federation?
Offer a terse response. -0.26. In the year 2010, what is the difference between the Expenditure(as % of GDP) of Niger and Expenditure(as % of GDP) of Serbia?
Your answer should be very brief. -4.08. In the year 2010, what is the difference between the Expenditure(as % of GDP) of Niger and Expenditure(as % of GDP) of Vanuatu?
Offer a very short reply. 1.98. In the year 2010, what is the difference between the Expenditure(as % of GDP) in Russian Federation and Expenditure(as % of GDP) in Serbia?
Give a very brief answer. -3.82. In the year 2010, what is the difference between the Expenditure(as % of GDP) of Russian Federation and Expenditure(as % of GDP) of Vanuatu?
Your response must be concise. 2.25. In the year 2010, what is the difference between the Expenditure(as % of GDP) in Serbia and Expenditure(as % of GDP) in Vanuatu?
Provide a succinct answer. 6.06. In the year 2011, what is the difference between the Expenditure(as % of GDP) of Niger and Expenditure(as % of GDP) of Russian Federation?
Offer a very short reply. 0.05. In the year 2011, what is the difference between the Expenditure(as % of GDP) in Niger and Expenditure(as % of GDP) in Serbia?
Provide a succinct answer. -3.54. In the year 2011, what is the difference between the Expenditure(as % of GDP) of Niger and Expenditure(as % of GDP) of Vanuatu?
Ensure brevity in your answer.  2.95. In the year 2011, what is the difference between the Expenditure(as % of GDP) in Russian Federation and Expenditure(as % of GDP) in Serbia?
Your answer should be compact. -3.59. In the year 2011, what is the difference between the Expenditure(as % of GDP) in Russian Federation and Expenditure(as % of GDP) in Vanuatu?
Make the answer very short. 2.9. In the year 2011, what is the difference between the Expenditure(as % of GDP) in Serbia and Expenditure(as % of GDP) in Vanuatu?
Your response must be concise. 6.49. In the year 2012, what is the difference between the Expenditure(as % of GDP) of Niger and Expenditure(as % of GDP) of Russian Federation?
Keep it short and to the point. -0.44. In the year 2012, what is the difference between the Expenditure(as % of GDP) of Niger and Expenditure(as % of GDP) of Serbia?
Provide a succinct answer. -4.52. In the year 2012, what is the difference between the Expenditure(as % of GDP) of Niger and Expenditure(as % of GDP) of Vanuatu?
Offer a terse response. 2.43. In the year 2012, what is the difference between the Expenditure(as % of GDP) of Russian Federation and Expenditure(as % of GDP) of Serbia?
Your answer should be compact. -4.08. In the year 2012, what is the difference between the Expenditure(as % of GDP) of Russian Federation and Expenditure(as % of GDP) of Vanuatu?
Your response must be concise. 2.87. In the year 2012, what is the difference between the Expenditure(as % of GDP) of Serbia and Expenditure(as % of GDP) of Vanuatu?
Offer a very short reply. 6.95. In the year 2013, what is the difference between the Expenditure(as % of GDP) of Niger and Expenditure(as % of GDP) of Russian Federation?
Your answer should be very brief. 0. In the year 2013, what is the difference between the Expenditure(as % of GDP) of Niger and Expenditure(as % of GDP) of Serbia?
Your response must be concise. -4.05. In the year 2013, what is the difference between the Expenditure(as % of GDP) in Niger and Expenditure(as % of GDP) in Vanuatu?
Offer a very short reply. 2.7. In the year 2013, what is the difference between the Expenditure(as % of GDP) of Russian Federation and Expenditure(as % of GDP) of Serbia?
Your answer should be very brief. -4.05. In the year 2013, what is the difference between the Expenditure(as % of GDP) of Russian Federation and Expenditure(as % of GDP) of Vanuatu?
Keep it short and to the point. 2.69. In the year 2013, what is the difference between the Expenditure(as % of GDP) of Serbia and Expenditure(as % of GDP) of Vanuatu?
Make the answer very short. 6.74. What is the ratio of the Expenditure(as % of GDP) in Niger in 2006 to that in 2007?
Provide a short and direct response. 1.08. What is the ratio of the Expenditure(as % of GDP) of Serbia in 2006 to that in 2007?
Ensure brevity in your answer.  0.91. What is the ratio of the Expenditure(as % of GDP) in Vanuatu in 2006 to that in 2007?
Provide a short and direct response. 0.85. What is the ratio of the Expenditure(as % of GDP) of Niger in 2006 to that in 2008?
Make the answer very short. 1.06. What is the ratio of the Expenditure(as % of GDP) in Russian Federation in 2006 to that in 2008?
Keep it short and to the point. 0.86. What is the ratio of the Expenditure(as % of GDP) in Serbia in 2006 to that in 2008?
Provide a succinct answer. 0.91. What is the ratio of the Expenditure(as % of GDP) in Vanuatu in 2006 to that in 2008?
Ensure brevity in your answer.  0.85. What is the ratio of the Expenditure(as % of GDP) in Niger in 2006 to that in 2009?
Make the answer very short. 1.01. What is the ratio of the Expenditure(as % of GDP) in Russian Federation in 2006 to that in 2009?
Your answer should be very brief. 0.7. What is the ratio of the Expenditure(as % of GDP) in Serbia in 2006 to that in 2009?
Give a very brief answer. 0.9. What is the ratio of the Expenditure(as % of GDP) in Vanuatu in 2006 to that in 2009?
Give a very brief answer. 0.8. What is the ratio of the Expenditure(as % of GDP) in Niger in 2006 to that in 2010?
Give a very brief answer. 1.1. What is the ratio of the Expenditure(as % of GDP) in Russian Federation in 2006 to that in 2010?
Provide a short and direct response. 0.77. What is the ratio of the Expenditure(as % of GDP) in Serbia in 2006 to that in 2010?
Provide a succinct answer. 0.88. What is the ratio of the Expenditure(as % of GDP) in Vanuatu in 2006 to that in 2010?
Keep it short and to the point. 0.67. What is the ratio of the Expenditure(as % of GDP) of Niger in 2006 to that in 2011?
Give a very brief answer. 1.08. What is the ratio of the Expenditure(as % of GDP) in Russian Federation in 2006 to that in 2011?
Offer a terse response. 0.79. What is the ratio of the Expenditure(as % of GDP) of Serbia in 2006 to that in 2011?
Ensure brevity in your answer.  0.91. What is the ratio of the Expenditure(as % of GDP) in Vanuatu in 2006 to that in 2011?
Keep it short and to the point. 0.81. What is the ratio of the Expenditure(as % of GDP) of Niger in 2006 to that in 2012?
Offer a terse response. 1.21. What is the ratio of the Expenditure(as % of GDP) of Russian Federation in 2006 to that in 2012?
Keep it short and to the point. 0.82. What is the ratio of the Expenditure(as % of GDP) of Serbia in 2006 to that in 2012?
Ensure brevity in your answer.  0.89. What is the ratio of the Expenditure(as % of GDP) of Vanuatu in 2006 to that in 2012?
Keep it short and to the point. 0.86. What is the ratio of the Expenditure(as % of GDP) of Niger in 2006 to that in 2013?
Provide a succinct answer. 1.12. What is the ratio of the Expenditure(as % of GDP) in Russian Federation in 2006 to that in 2013?
Provide a succinct answer. 0.81. What is the ratio of the Expenditure(as % of GDP) of Serbia in 2006 to that in 2013?
Give a very brief answer. 0.89. What is the ratio of the Expenditure(as % of GDP) of Vanuatu in 2006 to that in 2013?
Your answer should be compact. 0.81. What is the ratio of the Expenditure(as % of GDP) of Niger in 2007 to that in 2008?
Make the answer very short. 0.98. What is the ratio of the Expenditure(as % of GDP) of Russian Federation in 2007 to that in 2008?
Ensure brevity in your answer.  0.87. What is the ratio of the Expenditure(as % of GDP) in Niger in 2007 to that in 2009?
Give a very brief answer. 0.94. What is the ratio of the Expenditure(as % of GDP) in Russian Federation in 2007 to that in 2009?
Offer a terse response. 0.71. What is the ratio of the Expenditure(as % of GDP) of Serbia in 2007 to that in 2009?
Provide a succinct answer. 0.99. What is the ratio of the Expenditure(as % of GDP) of Vanuatu in 2007 to that in 2009?
Give a very brief answer. 0.94. What is the ratio of the Expenditure(as % of GDP) of Niger in 2007 to that in 2010?
Provide a short and direct response. 1.02. What is the ratio of the Expenditure(as % of GDP) of Russian Federation in 2007 to that in 2010?
Your answer should be compact. 0.78. What is the ratio of the Expenditure(as % of GDP) of Serbia in 2007 to that in 2010?
Provide a short and direct response. 0.96. What is the ratio of the Expenditure(as % of GDP) of Vanuatu in 2007 to that in 2010?
Provide a short and direct response. 0.79. What is the ratio of the Expenditure(as % of GDP) of Russian Federation in 2007 to that in 2011?
Keep it short and to the point. 0.8. What is the ratio of the Expenditure(as % of GDP) of Serbia in 2007 to that in 2011?
Your answer should be very brief. 1. What is the ratio of the Expenditure(as % of GDP) of Vanuatu in 2007 to that in 2011?
Keep it short and to the point. 0.96. What is the ratio of the Expenditure(as % of GDP) in Niger in 2007 to that in 2012?
Keep it short and to the point. 1.12. What is the ratio of the Expenditure(as % of GDP) of Russian Federation in 2007 to that in 2012?
Your answer should be very brief. 0.83. What is the ratio of the Expenditure(as % of GDP) in Serbia in 2007 to that in 2012?
Your response must be concise. 0.98. What is the ratio of the Expenditure(as % of GDP) in Niger in 2007 to that in 2013?
Provide a succinct answer. 1.03. What is the ratio of the Expenditure(as % of GDP) in Russian Federation in 2007 to that in 2013?
Your answer should be compact. 0.82. What is the ratio of the Expenditure(as % of GDP) of Serbia in 2007 to that in 2013?
Ensure brevity in your answer.  0.98. What is the ratio of the Expenditure(as % of GDP) of Vanuatu in 2007 to that in 2013?
Make the answer very short. 0.95. What is the ratio of the Expenditure(as % of GDP) of Russian Federation in 2008 to that in 2009?
Your answer should be compact. 0.82. What is the ratio of the Expenditure(as % of GDP) in Serbia in 2008 to that in 2009?
Give a very brief answer. 0.99. What is the ratio of the Expenditure(as % of GDP) of Vanuatu in 2008 to that in 2009?
Provide a succinct answer. 0.94. What is the ratio of the Expenditure(as % of GDP) of Niger in 2008 to that in 2010?
Your answer should be very brief. 1.04. What is the ratio of the Expenditure(as % of GDP) of Russian Federation in 2008 to that in 2010?
Offer a terse response. 0.89. What is the ratio of the Expenditure(as % of GDP) in Serbia in 2008 to that in 2010?
Keep it short and to the point. 0.97. What is the ratio of the Expenditure(as % of GDP) in Vanuatu in 2008 to that in 2010?
Ensure brevity in your answer.  0.79. What is the ratio of the Expenditure(as % of GDP) of Niger in 2008 to that in 2011?
Offer a very short reply. 1.02. What is the ratio of the Expenditure(as % of GDP) in Russian Federation in 2008 to that in 2011?
Keep it short and to the point. 0.92. What is the ratio of the Expenditure(as % of GDP) in Vanuatu in 2008 to that in 2011?
Your response must be concise. 0.96. What is the ratio of the Expenditure(as % of GDP) in Niger in 2008 to that in 2012?
Your answer should be compact. 1.14. What is the ratio of the Expenditure(as % of GDP) of Russian Federation in 2008 to that in 2012?
Provide a short and direct response. 0.95. What is the ratio of the Expenditure(as % of GDP) of Serbia in 2008 to that in 2012?
Your answer should be very brief. 0.98. What is the ratio of the Expenditure(as % of GDP) of Vanuatu in 2008 to that in 2012?
Your answer should be very brief. 1.01. What is the ratio of the Expenditure(as % of GDP) of Niger in 2008 to that in 2013?
Offer a very short reply. 1.06. What is the ratio of the Expenditure(as % of GDP) of Russian Federation in 2008 to that in 2013?
Offer a terse response. 0.94. What is the ratio of the Expenditure(as % of GDP) of Serbia in 2008 to that in 2013?
Your answer should be very brief. 0.98. What is the ratio of the Expenditure(as % of GDP) in Vanuatu in 2008 to that in 2013?
Your answer should be compact. 0.95. What is the ratio of the Expenditure(as % of GDP) in Niger in 2009 to that in 2010?
Provide a short and direct response. 1.08. What is the ratio of the Expenditure(as % of GDP) of Russian Federation in 2009 to that in 2010?
Your answer should be very brief. 1.09. What is the ratio of the Expenditure(as % of GDP) of Serbia in 2009 to that in 2010?
Your answer should be compact. 0.98. What is the ratio of the Expenditure(as % of GDP) in Vanuatu in 2009 to that in 2010?
Offer a very short reply. 0.83. What is the ratio of the Expenditure(as % of GDP) in Niger in 2009 to that in 2011?
Your answer should be very brief. 1.06. What is the ratio of the Expenditure(as % of GDP) in Russian Federation in 2009 to that in 2011?
Your answer should be very brief. 1.12. What is the ratio of the Expenditure(as % of GDP) of Serbia in 2009 to that in 2011?
Provide a short and direct response. 1.02. What is the ratio of the Expenditure(as % of GDP) in Vanuatu in 2009 to that in 2011?
Offer a very short reply. 1.02. What is the ratio of the Expenditure(as % of GDP) in Niger in 2009 to that in 2012?
Offer a terse response. 1.19. What is the ratio of the Expenditure(as % of GDP) of Russian Federation in 2009 to that in 2012?
Give a very brief answer. 1.16. What is the ratio of the Expenditure(as % of GDP) in Serbia in 2009 to that in 2012?
Provide a short and direct response. 0.99. What is the ratio of the Expenditure(as % of GDP) of Vanuatu in 2009 to that in 2012?
Your response must be concise. 1.07. What is the ratio of the Expenditure(as % of GDP) of Niger in 2009 to that in 2013?
Make the answer very short. 1.1. What is the ratio of the Expenditure(as % of GDP) of Russian Federation in 2009 to that in 2013?
Your answer should be very brief. 1.15. What is the ratio of the Expenditure(as % of GDP) of Serbia in 2009 to that in 2013?
Ensure brevity in your answer.  0.99. What is the ratio of the Expenditure(as % of GDP) of Vanuatu in 2009 to that in 2013?
Keep it short and to the point. 1.01. What is the ratio of the Expenditure(as % of GDP) of Niger in 2010 to that in 2011?
Give a very brief answer. 0.98. What is the ratio of the Expenditure(as % of GDP) in Russian Federation in 2010 to that in 2011?
Your response must be concise. 1.03. What is the ratio of the Expenditure(as % of GDP) of Serbia in 2010 to that in 2011?
Your answer should be very brief. 1.04. What is the ratio of the Expenditure(as % of GDP) of Vanuatu in 2010 to that in 2011?
Offer a terse response. 1.22. What is the ratio of the Expenditure(as % of GDP) of Niger in 2010 to that in 2012?
Offer a terse response. 1.1. What is the ratio of the Expenditure(as % of GDP) in Russian Federation in 2010 to that in 2012?
Offer a terse response. 1.06. What is the ratio of the Expenditure(as % of GDP) of Serbia in 2010 to that in 2012?
Give a very brief answer. 1.01. What is the ratio of the Expenditure(as % of GDP) in Vanuatu in 2010 to that in 2012?
Provide a succinct answer. 1.29. What is the ratio of the Expenditure(as % of GDP) in Niger in 2010 to that in 2013?
Make the answer very short. 1.02. What is the ratio of the Expenditure(as % of GDP) in Russian Federation in 2010 to that in 2013?
Your answer should be very brief. 1.06. What is the ratio of the Expenditure(as % of GDP) of Serbia in 2010 to that in 2013?
Keep it short and to the point. 1.01. What is the ratio of the Expenditure(as % of GDP) in Vanuatu in 2010 to that in 2013?
Ensure brevity in your answer.  1.21. What is the ratio of the Expenditure(as % of GDP) in Niger in 2011 to that in 2012?
Keep it short and to the point. 1.12. What is the ratio of the Expenditure(as % of GDP) in Russian Federation in 2011 to that in 2012?
Your answer should be very brief. 1.04. What is the ratio of the Expenditure(as % of GDP) in Serbia in 2011 to that in 2012?
Offer a very short reply. 0.98. What is the ratio of the Expenditure(as % of GDP) in Vanuatu in 2011 to that in 2012?
Offer a terse response. 1.06. What is the ratio of the Expenditure(as % of GDP) of Niger in 2011 to that in 2013?
Ensure brevity in your answer.  1.04. What is the ratio of the Expenditure(as % of GDP) of Russian Federation in 2011 to that in 2013?
Your answer should be very brief. 1.03. What is the ratio of the Expenditure(as % of GDP) of Serbia in 2011 to that in 2013?
Your response must be concise. 0.97. What is the ratio of the Expenditure(as % of GDP) in Vanuatu in 2011 to that in 2013?
Your answer should be very brief. 1. What is the ratio of the Expenditure(as % of GDP) in Niger in 2012 to that in 2013?
Give a very brief answer. 0.93. What is the ratio of the Expenditure(as % of GDP) of Russian Federation in 2012 to that in 2013?
Your answer should be very brief. 0.99. What is the ratio of the Expenditure(as % of GDP) of Vanuatu in 2012 to that in 2013?
Offer a very short reply. 0.94. What is the difference between the highest and the second highest Expenditure(as % of GDP) in Niger?
Your answer should be very brief. 0.1. What is the difference between the highest and the second highest Expenditure(as % of GDP) in Russian Federation?
Keep it short and to the point. 0.61. What is the difference between the highest and the second highest Expenditure(as % of GDP) in Serbia?
Offer a terse response. 0.14. What is the difference between the highest and the second highest Expenditure(as % of GDP) of Vanuatu?
Provide a short and direct response. 0.77. What is the difference between the highest and the lowest Expenditure(as % of GDP) of Niger?
Offer a terse response. 1.25. What is the difference between the highest and the lowest Expenditure(as % of GDP) of Russian Federation?
Your response must be concise. 2.22. What is the difference between the highest and the lowest Expenditure(as % of GDP) in Serbia?
Your response must be concise. 1.32. What is the difference between the highest and the lowest Expenditure(as % of GDP) of Vanuatu?
Your response must be concise. 1.57. 